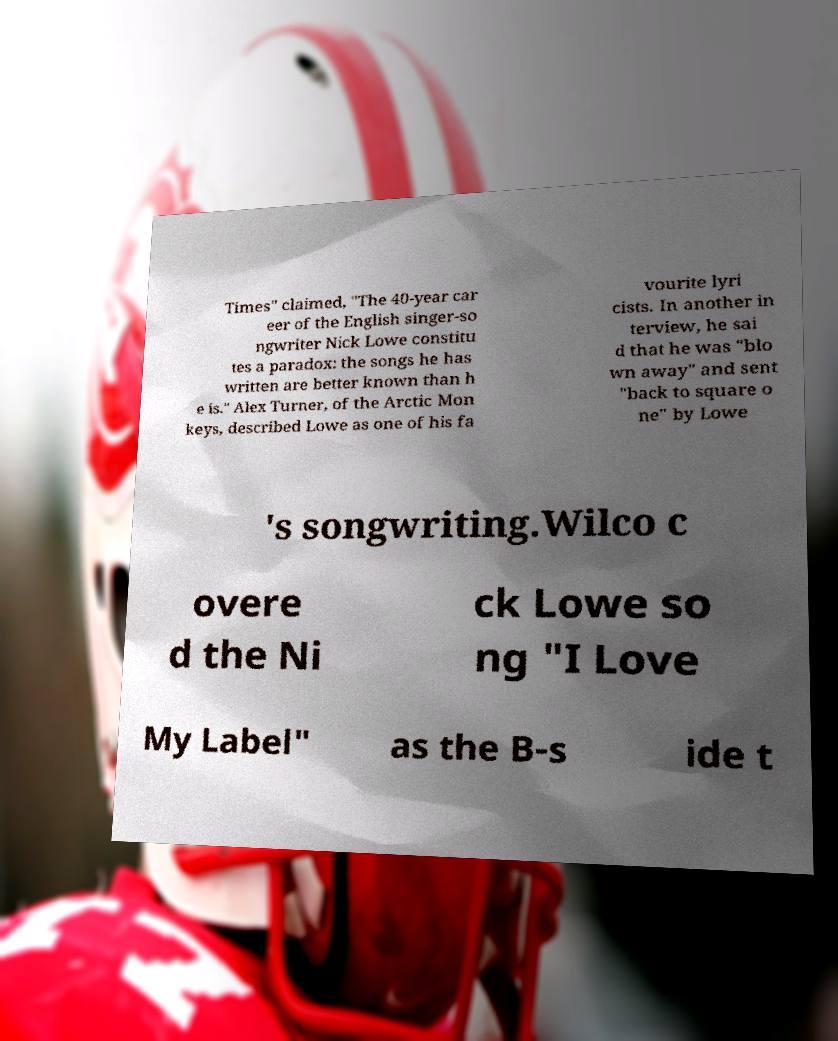There's text embedded in this image that I need extracted. Can you transcribe it verbatim? Times" claimed, "The 40-year car eer of the English singer-so ngwriter Nick Lowe constitu tes a paradox: the songs he has written are better known than h e is." Alex Turner, of the Arctic Mon keys, described Lowe as one of his fa vourite lyri cists. In another in terview, he sai d that he was "blo wn away" and sent "back to square o ne" by Lowe 's songwriting.Wilco c overe d the Ni ck Lowe so ng "I Love My Label" as the B-s ide t 